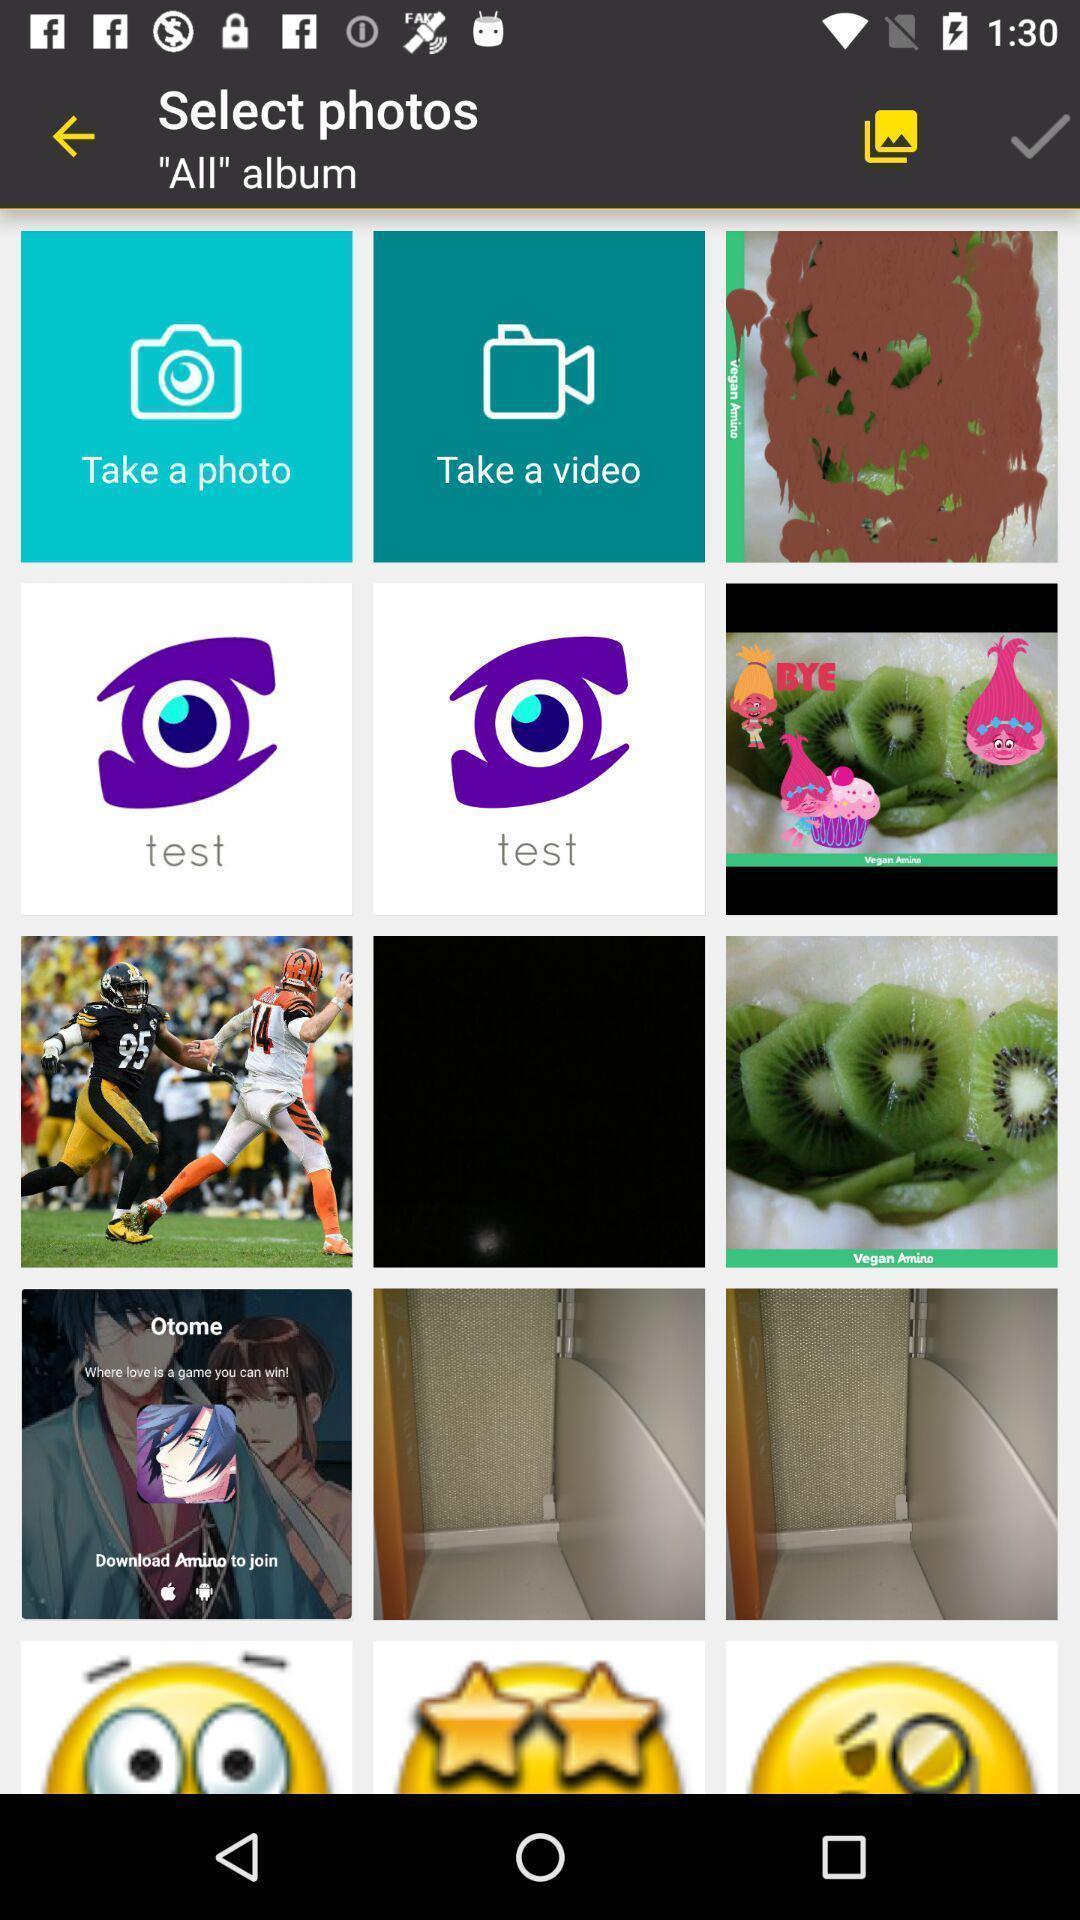Describe the content in this image. Page displaying with list of different images. 